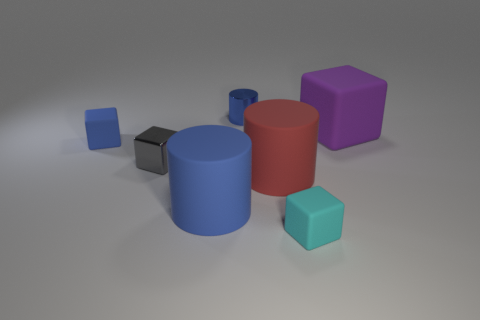Subtract all red blocks. How many blue cylinders are left? 2 Add 1 metallic cylinders. How many objects exist? 8 Subtract all gray blocks. How many blocks are left? 3 Subtract all small blocks. How many blocks are left? 1 Subtract all cubes. How many objects are left? 3 Subtract all brown cylinders. Subtract all gray blocks. How many cylinders are left? 3 Subtract all large rubber cubes. Subtract all tiny metal cylinders. How many objects are left? 5 Add 4 small matte blocks. How many small matte blocks are left? 6 Add 7 purple rubber blocks. How many purple rubber blocks exist? 8 Subtract 0 purple cylinders. How many objects are left? 7 